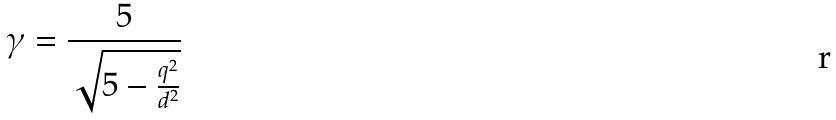Convert formula to latex. <formula><loc_0><loc_0><loc_500><loc_500>\gamma = \frac { 5 } { \sqrt { 5 - \frac { q ^ { 2 } } { d ^ { 2 } } } }</formula> 